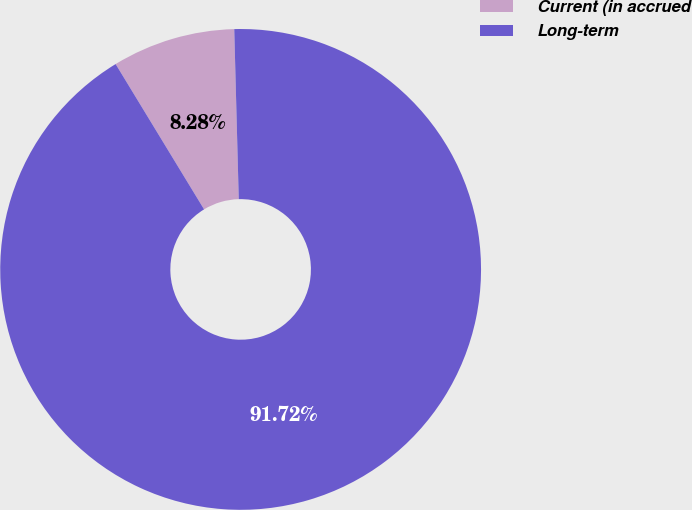Convert chart. <chart><loc_0><loc_0><loc_500><loc_500><pie_chart><fcel>Current (in accrued<fcel>Long-term<nl><fcel>8.28%<fcel>91.72%<nl></chart> 